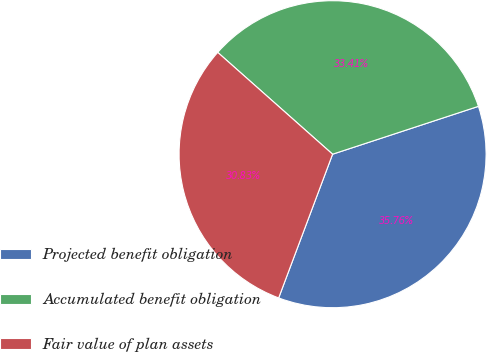Convert chart to OTSL. <chart><loc_0><loc_0><loc_500><loc_500><pie_chart><fcel>Projected benefit obligation<fcel>Accumulated benefit obligation<fcel>Fair value of plan assets<nl><fcel>35.76%<fcel>33.41%<fcel>30.83%<nl></chart> 